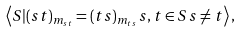Convert formula to latex. <formula><loc_0><loc_0><loc_500><loc_500>\left \langle S | ( s t ) _ { m _ { s t } } = ( t s ) _ { m _ { t s } } \, s , t \in S \, s \neq t \right \rangle ,</formula> 